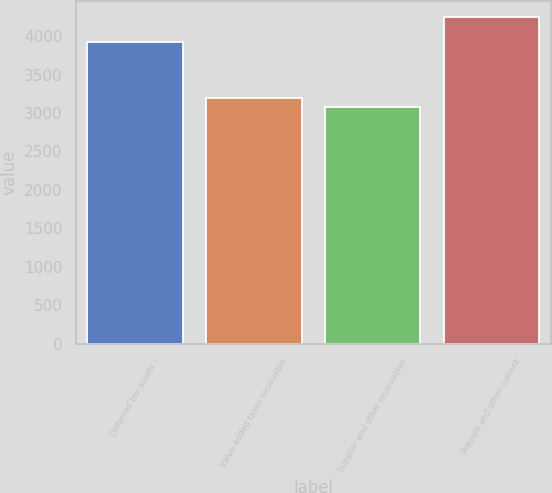<chart> <loc_0><loc_0><loc_500><loc_500><bar_chart><fcel>Deferred tax assets -<fcel>Value added taxes receivable<fcel>Supplier and other receivables<fcel>Prepaid and other current<nl><fcel>3920<fcel>3198.2<fcel>3082<fcel>4244<nl></chart> 